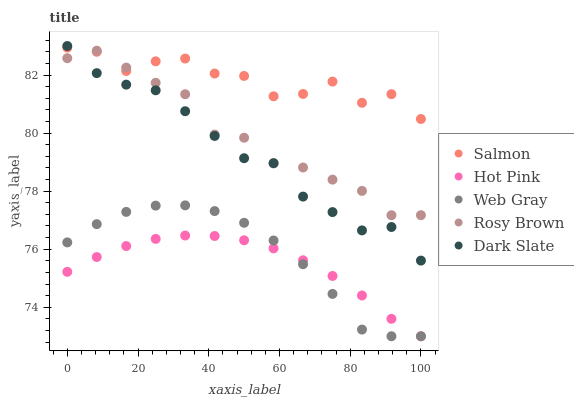Does Hot Pink have the minimum area under the curve?
Answer yes or no. Yes. Does Salmon have the maximum area under the curve?
Answer yes or no. Yes. Does Dark Slate have the minimum area under the curve?
Answer yes or no. No. Does Dark Slate have the maximum area under the curve?
Answer yes or no. No. Is Hot Pink the smoothest?
Answer yes or no. Yes. Is Salmon the roughest?
Answer yes or no. Yes. Is Dark Slate the smoothest?
Answer yes or no. No. Is Dark Slate the roughest?
Answer yes or no. No. Does Web Gray have the lowest value?
Answer yes or no. Yes. Does Dark Slate have the lowest value?
Answer yes or no. No. Does Dark Slate have the highest value?
Answer yes or no. Yes. Does Rosy Brown have the highest value?
Answer yes or no. No. Is Web Gray less than Rosy Brown?
Answer yes or no. Yes. Is Dark Slate greater than Web Gray?
Answer yes or no. Yes. Does Dark Slate intersect Rosy Brown?
Answer yes or no. Yes. Is Dark Slate less than Rosy Brown?
Answer yes or no. No. Is Dark Slate greater than Rosy Brown?
Answer yes or no. No. Does Web Gray intersect Rosy Brown?
Answer yes or no. No. 